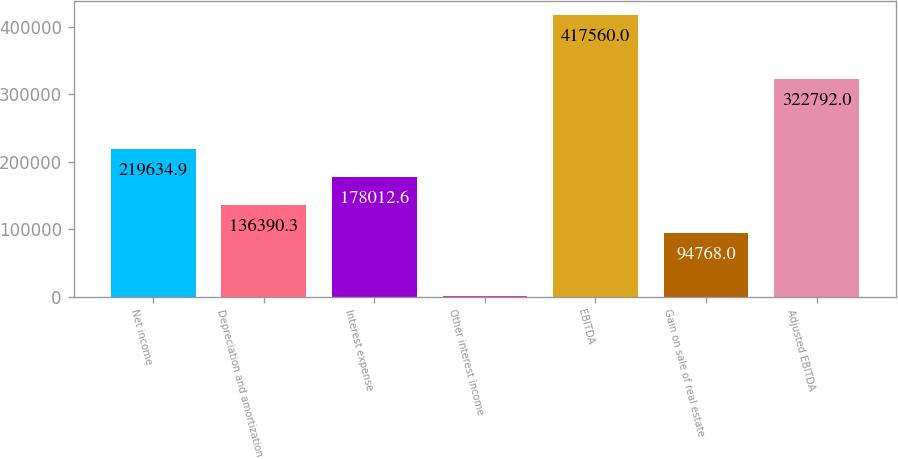<chart> <loc_0><loc_0><loc_500><loc_500><bar_chart><fcel>Net income<fcel>Depreciation and amortization<fcel>Interest expense<fcel>Other interest income<fcel>EBITDA<fcel>Gain on sale of real estate<fcel>Adjusted EBITDA<nl><fcel>219635<fcel>136390<fcel>178013<fcel>1337<fcel>417560<fcel>94768<fcel>322792<nl></chart> 